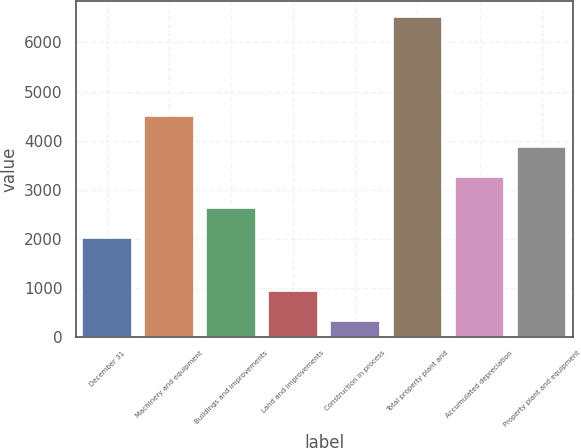Convert chart to OTSL. <chart><loc_0><loc_0><loc_500><loc_500><bar_chart><fcel>December 31<fcel>Machinery and equipment<fcel>Buildings and improvements<fcel>Land and improvements<fcel>Construction in process<fcel>Total property plant and<fcel>Accumulated depreciation<fcel>Property plant and equipment<nl><fcel>2011<fcel>4493<fcel>2631.5<fcel>933.5<fcel>313<fcel>6518<fcel>3252<fcel>3872.5<nl></chart> 